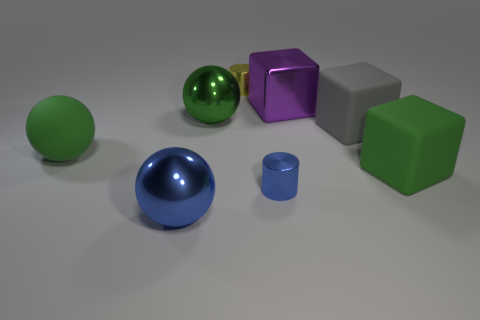Does the large rubber ball have the same color as the shiny sphere behind the tiny blue thing?
Offer a very short reply. Yes. Does the metallic cylinder that is left of the tiny blue metallic cylinder have the same size as the matte block in front of the gray object?
Give a very brief answer. No. How many other objects are made of the same material as the small yellow object?
Offer a terse response. 4. How many large metallic balls are in front of the big green ball behind the large green rubber thing that is on the left side of the gray matte block?
Your answer should be compact. 1. Is the gray rubber object the same shape as the small yellow shiny object?
Provide a short and direct response. No. Is there a green matte thing that has the same shape as the large blue object?
Your answer should be very brief. Yes. What is the shape of the purple metallic thing that is the same size as the gray rubber cube?
Your answer should be compact. Cube. What is the material of the large green thing that is in front of the green rubber object to the left of the cylinder that is behind the big green metal thing?
Offer a terse response. Rubber. Do the yellow cylinder and the blue metal cylinder have the same size?
Keep it short and to the point. Yes. What is the purple cube made of?
Your response must be concise. Metal. 